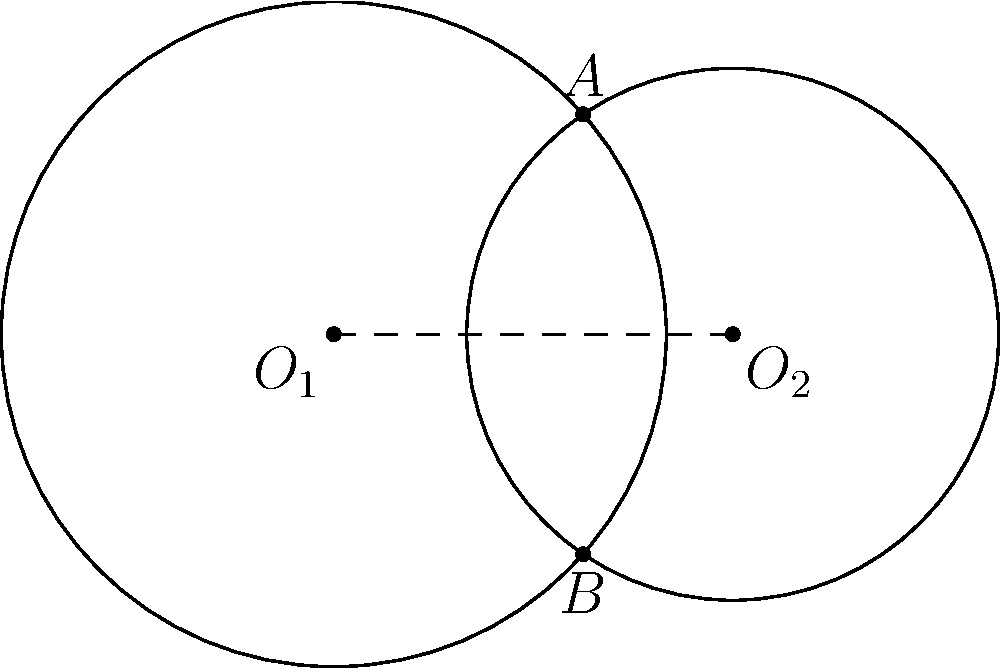As part of your web browser accessibility project, you need to calculate the area between two intersecting circles to improve the visual representation of overlapping elements. Given two circles with centers $O_1(0,0)$ and $O_2(3,0)$, and radii $r_1=2.5$ and $r_2=2$ respectively, calculate the area of the region between the two circles (the lens-shaped area). Round your answer to two decimal places. To solve this problem, we'll follow these steps:

1) First, we need to find the distance between the centers of the circles:
   $d = 3$ (given in the coordinates of $O_2$)

2) Now, we need to find the angle $\theta$ (in radians) at the center of each circle subtended by the chord connecting the intersection points:

   For circle 1: $\cos(\frac{\theta_1}{2}) = \frac{d^2 + r_1^2 - r_2^2}{2dr_1}$
                 $\cos(\frac{\theta_1}{2}) = \frac{3^2 + 2.5^2 - 2^2}{2(3)(2.5)} = 0.7$
                 $\theta_1 = 2 \arccos(0.7) = 1.5904$ radians

   For circle 2: $\cos(\frac{\theta_2}{2}) = \frac{d^2 + r_2^2 - r_1^2}{2dr_2}$
                 $\cos(\frac{\theta_2}{2}) = \frac{3^2 + 2^2 - 2.5^2}{2(3)(2)} = 0.5417$
                 $\theta_2 = 2 \arccos(0.5417) = 2.0944$ radians

3) The area of the lens is the sum of the areas of the two circular sectors minus the area of the rhombus formed by the radii:

   Area of sector 1 = $\frac{1}{2}r_1^2\theta_1 = \frac{1}{2}(2.5)^2(1.5904) = 4.9700$
   Area of sector 2 = $\frac{1}{2}r_2^2\theta_2 = \frac{1}{2}(2)^2(2.0944) = 4.1888$

   Area of rhombus = $d\sqrt{r_1^2 - (\frac{d}{2})^2} = 3\sqrt{2.5^2 - (\frac{3}{2})^2} = 6.0622$

4) Therefore, the area of the lens is:
   $A = 4.9700 + 4.1888 - 6.0622 = 3.0966$

Rounding to two decimal places, we get 3.10 square units.
Answer: 3.10 square units 